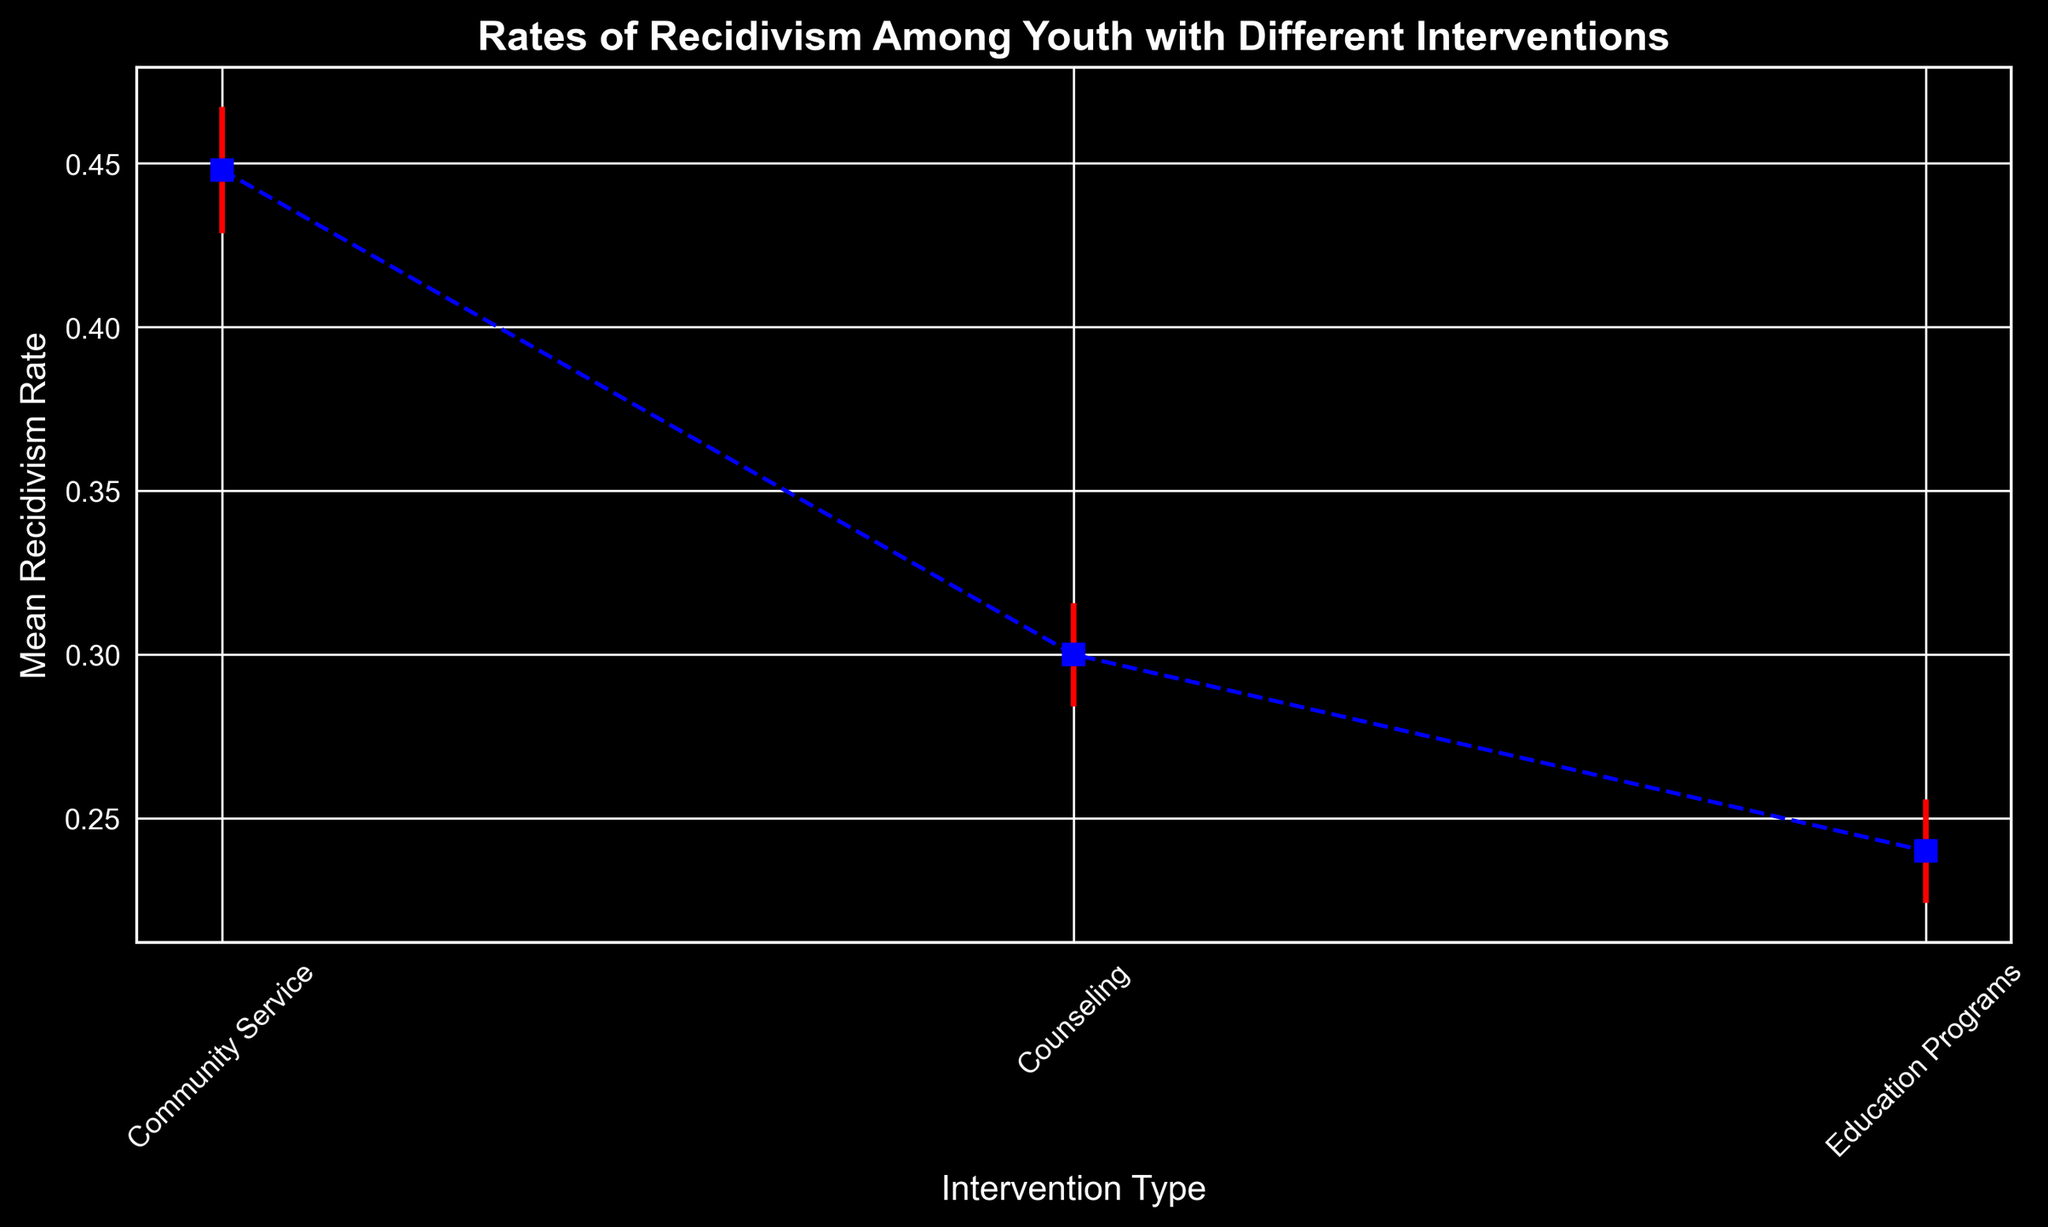what's the mean recidivism rate for Counseling? Look for the y-value associated with Counseling on the x-axis. The error bar plot shows the mean rate for Counseling.
Answer: 0.30 Which intervention has the highest mean recidivism rate? Compare the y-values (mean recidivism rates) for all interventions. Community Service has the highest value compared to Counseling and Education Programs.
Answer: Community Service How much higher is the mean recidivism rate for Community Service compared to Education Programs? Find the means for both Community Service (0.45) and Education Programs (0.24) and subtract the latter from the former.
Answer: 0.21 What is the range of recidivism rates for Counseling given the error bars? The mean for Counseling is 0.30, with errors of +/-0.05. Add and subtract this error from the mean to find the range.
Answer: 0.25 to 0.35 Which intervention has the smallest error in recidivism rate measurement? Look for the smallest length of the error bars (vertical red lines) among all interventions. Education Programs has the smallest error.
Answer: Education Programs How does the mean recidivism rate of Counseling compare to that of Education Programs? Compare the y-values of Counseling (0.30) and Education Programs (0.24). Counseling has a higher mean rate.
Answer: Counseling is higher What's the difference between the upper limit of the error bars for Community Service and the lower limit for Education Programs? Calculate the upper limit for Community Service (0.45 + 0.07 = 0.52) and the lower limit for Education Programs (0.24 - 0.04 = 0.20), then find the difference.
Answer: 0.32 Which intervention shows the highest variability in recidivism rates? The intervention with the largest error bar length represents the highest variability. Community Service has the largest error bar.
Answer: Community Service What's the average mean recidivism rate across all interventions? Add the means of all interventions (0.30 + 0.45 + 0.24) and divide by the number of interventions (3).
Answer: 0.33 If you combine the upper error bounds for Education Programs and Counseling, do they exceed the upper error bound for Community Service? Calculate the upper error bounds for Education Programs (0.24 + 0.05 = 0.29) and Counseling (0.30 + 0.06 = 0.36). The combined bound is 0.65, which exceeds Community Service's upper bound (0.45 + 0.07 = 0.52).
Answer: Yes 